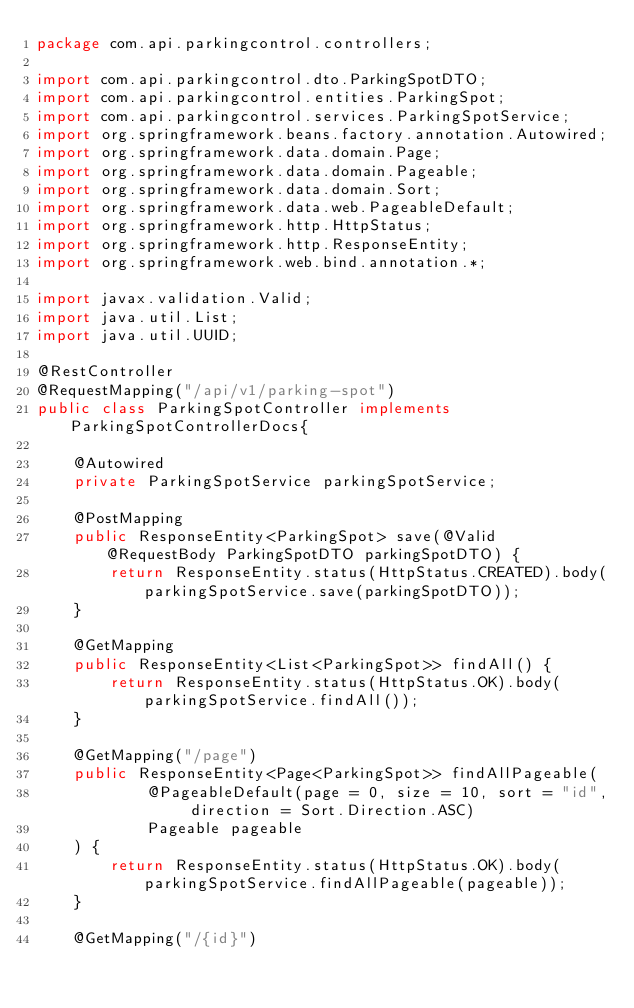Convert code to text. <code><loc_0><loc_0><loc_500><loc_500><_Java_>package com.api.parkingcontrol.controllers;

import com.api.parkingcontrol.dto.ParkingSpotDTO;
import com.api.parkingcontrol.entities.ParkingSpot;
import com.api.parkingcontrol.services.ParkingSpotService;
import org.springframework.beans.factory.annotation.Autowired;
import org.springframework.data.domain.Page;
import org.springframework.data.domain.Pageable;
import org.springframework.data.domain.Sort;
import org.springframework.data.web.PageableDefault;
import org.springframework.http.HttpStatus;
import org.springframework.http.ResponseEntity;
import org.springframework.web.bind.annotation.*;

import javax.validation.Valid;
import java.util.List;
import java.util.UUID;

@RestController
@RequestMapping("/api/v1/parking-spot")
public class ParkingSpotController implements ParkingSpotControllerDocs{

    @Autowired
    private ParkingSpotService parkingSpotService;

    @PostMapping
    public ResponseEntity<ParkingSpot> save(@Valid @RequestBody ParkingSpotDTO parkingSpotDTO) {
        return ResponseEntity.status(HttpStatus.CREATED).body(parkingSpotService.save(parkingSpotDTO));
    }

    @GetMapping
    public ResponseEntity<List<ParkingSpot>> findAll() {
        return ResponseEntity.status(HttpStatus.OK).body(parkingSpotService.findAll());
    }

    @GetMapping("/page")
    public ResponseEntity<Page<ParkingSpot>> findAllPageable(
            @PageableDefault(page = 0, size = 10, sort = "id", direction = Sort.Direction.ASC)
            Pageable pageable
    ) {
        return ResponseEntity.status(HttpStatus.OK).body(parkingSpotService.findAllPageable(pageable));
    }

    @GetMapping("/{id}")</code> 